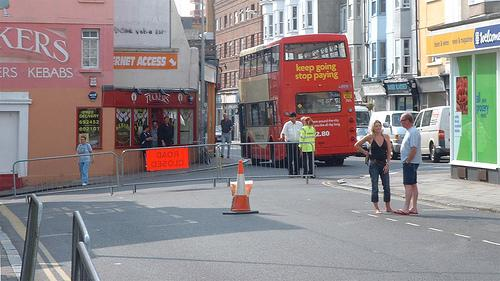Where are these 2 people standing? street 